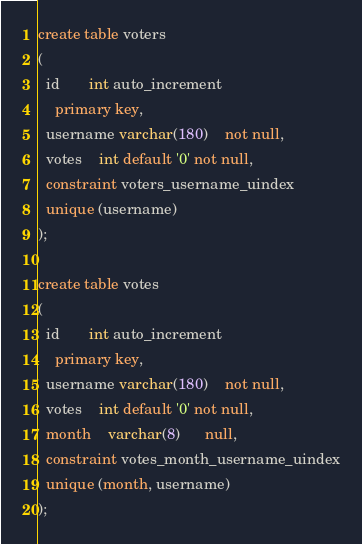Convert code to text. <code><loc_0><loc_0><loc_500><loc_500><_SQL_>create table voters
(
  id       int auto_increment
    primary key,
  username varchar(180)    not null,
  votes    int default '0' not null,
  constraint voters_username_uindex
  unique (username)
);

create table votes
(
  id       int auto_increment
    primary key,
  username varchar(180)    not null,
  votes    int default '0' not null,
  month    varchar(8)      null,
  constraint votes_month_username_uindex
  unique (month, username)
);
</code> 